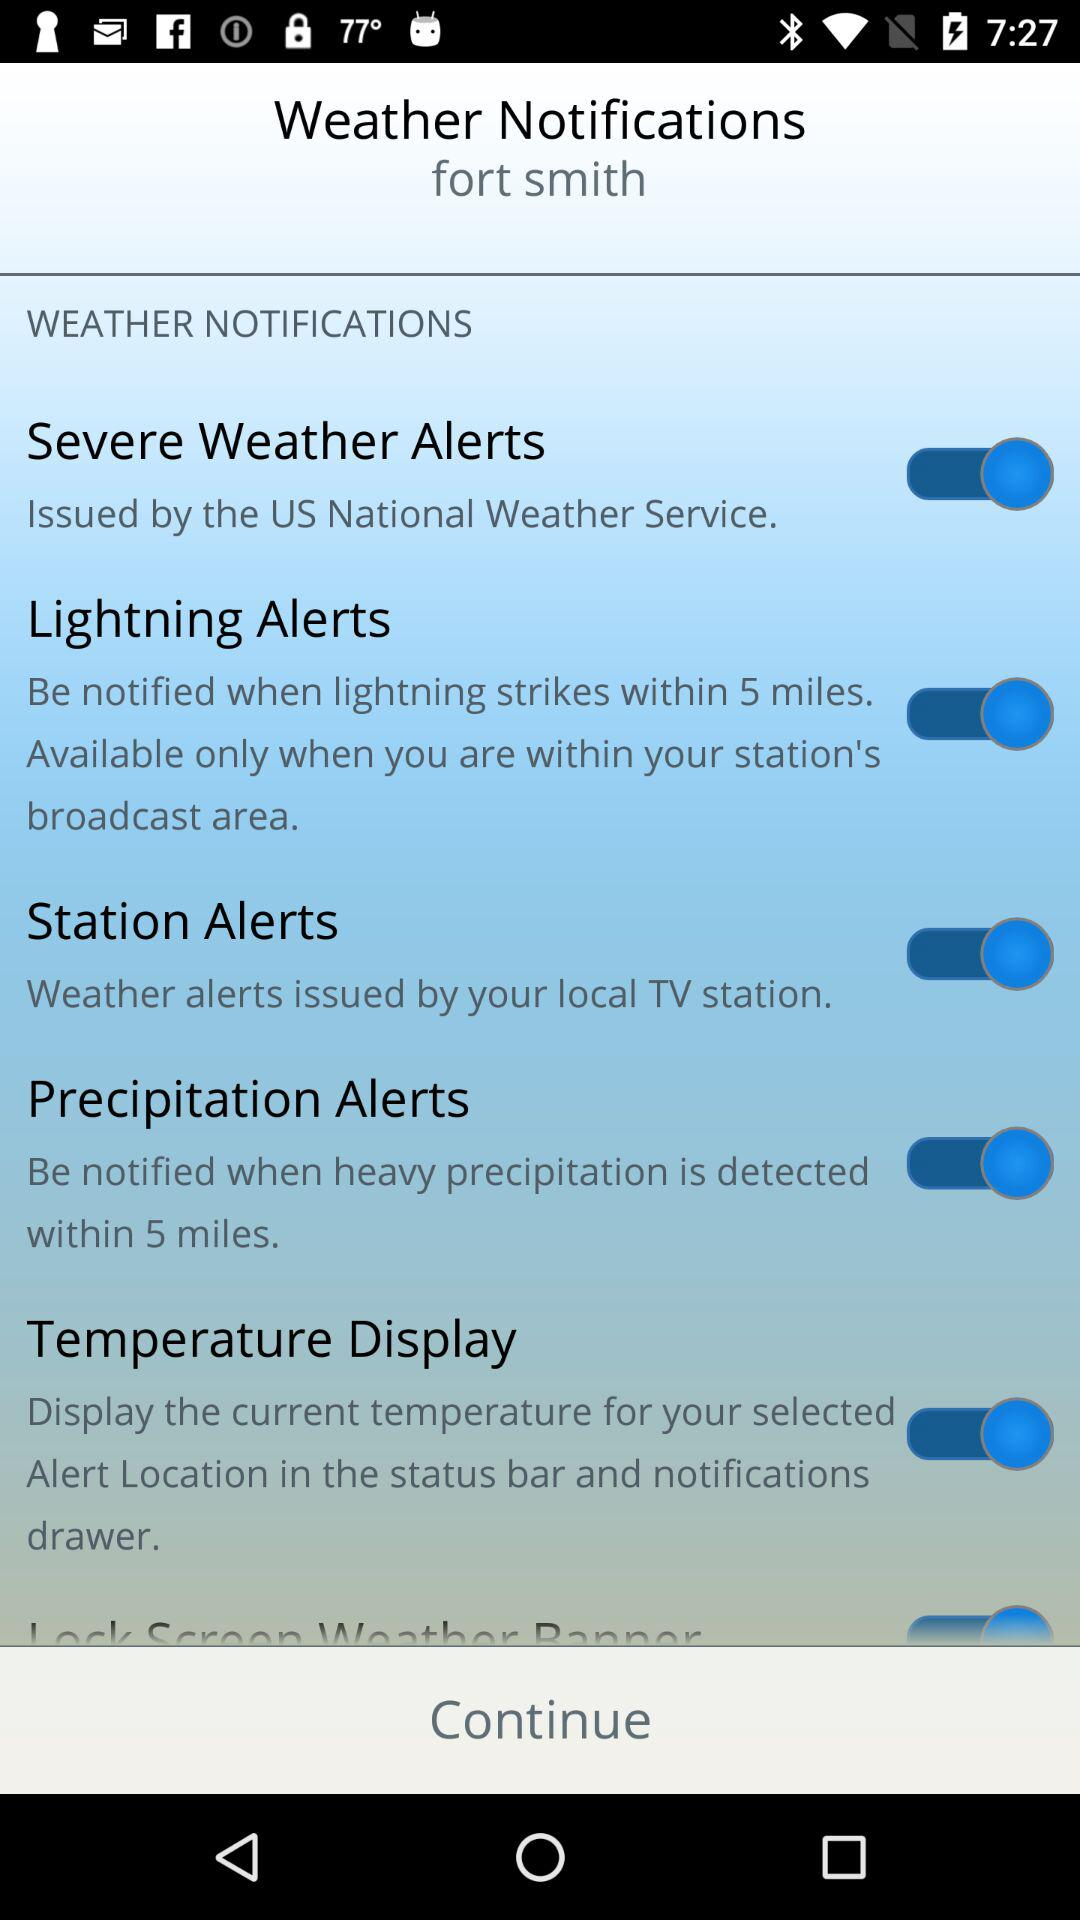What is the status of the "Station Alerts" notifications setting? The status is on. 